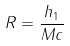Convert formula to latex. <formula><loc_0><loc_0><loc_500><loc_500>R = \frac { h _ { 1 } } { M c }</formula> 